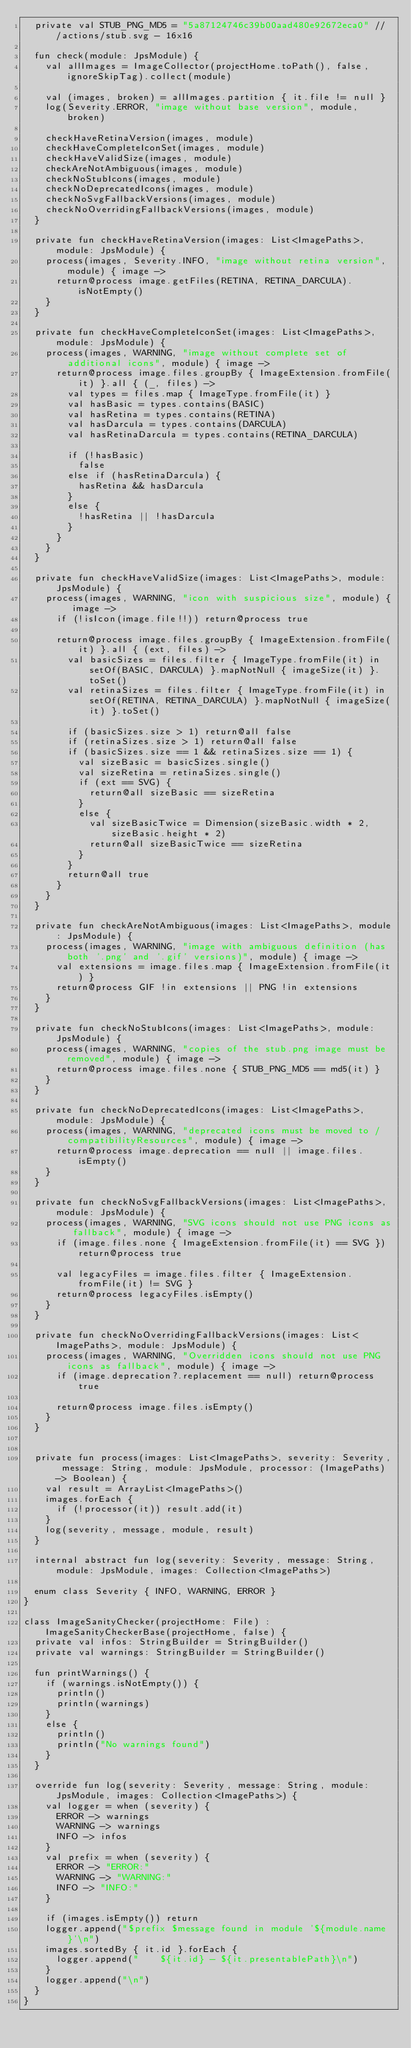Convert code to text. <code><loc_0><loc_0><loc_500><loc_500><_Kotlin_>  private val STUB_PNG_MD5 = "5a87124746c39b00aad480e92672eca0" // /actions/stub.svg - 16x16

  fun check(module: JpsModule) {
    val allImages = ImageCollector(projectHome.toPath(), false, ignoreSkipTag).collect(module)

    val (images, broken) = allImages.partition { it.file != null }
    log(Severity.ERROR, "image without base version", module, broken)

    checkHaveRetinaVersion(images, module)
    checkHaveCompleteIconSet(images, module)
    checkHaveValidSize(images, module)
    checkAreNotAmbiguous(images, module)
    checkNoStubIcons(images, module)
    checkNoDeprecatedIcons(images, module)
    checkNoSvgFallbackVersions(images, module)
    checkNoOverridingFallbackVersions(images, module)
  }

  private fun checkHaveRetinaVersion(images: List<ImagePaths>, module: JpsModule) {
    process(images, Severity.INFO, "image without retina version", module) { image ->
      return@process image.getFiles(RETINA, RETINA_DARCULA).isNotEmpty()
    }
  }

  private fun checkHaveCompleteIconSet(images: List<ImagePaths>, module: JpsModule) {
    process(images, WARNING, "image without complete set of additional icons", module) { image ->
      return@process image.files.groupBy { ImageExtension.fromFile(it) }.all { (_, files) ->
        val types = files.map { ImageType.fromFile(it) }
        val hasBasic = types.contains(BASIC)
        val hasRetina = types.contains(RETINA)
        val hasDarcula = types.contains(DARCULA)
        val hasRetinaDarcula = types.contains(RETINA_DARCULA)

        if (!hasBasic)
          false
        else if (hasRetinaDarcula) {
          hasRetina && hasDarcula
        }
        else {
          !hasRetina || !hasDarcula
        }
      }
    }
  }

  private fun checkHaveValidSize(images: List<ImagePaths>, module: JpsModule) {
    process(images, WARNING, "icon with suspicious size", module) { image ->
      if (!isIcon(image.file!!)) return@process true

      return@process image.files.groupBy { ImageExtension.fromFile(it) }.all { (ext, files) ->
        val basicSizes = files.filter { ImageType.fromFile(it) in setOf(BASIC, DARCULA) }.mapNotNull { imageSize(it) }.toSet()
        val retinaSizes = files.filter { ImageType.fromFile(it) in setOf(RETINA, RETINA_DARCULA) }.mapNotNull { imageSize(it) }.toSet()

        if (basicSizes.size > 1) return@all false
        if (retinaSizes.size > 1) return@all false
        if (basicSizes.size == 1 && retinaSizes.size == 1) {
          val sizeBasic = basicSizes.single()
          val sizeRetina = retinaSizes.single()
          if (ext == SVG) {
            return@all sizeBasic == sizeRetina
          }
          else {
            val sizeBasicTwice = Dimension(sizeBasic.width * 2, sizeBasic.height * 2)
            return@all sizeBasicTwice == sizeRetina
          }
        }
        return@all true
      }
    }
  }

  private fun checkAreNotAmbiguous(images: List<ImagePaths>, module: JpsModule) {
    process(images, WARNING, "image with ambiguous definition (has both '.png' and '.gif' versions)", module) { image ->
      val extensions = image.files.map { ImageExtension.fromFile(it) }
      return@process GIF !in extensions || PNG !in extensions
    }
  }

  private fun checkNoStubIcons(images: List<ImagePaths>, module: JpsModule) {
    process(images, WARNING, "copies of the stub.png image must be removed", module) { image ->
      return@process image.files.none { STUB_PNG_MD5 == md5(it) }
    }
  }

  private fun checkNoDeprecatedIcons(images: List<ImagePaths>, module: JpsModule) {
    process(images, WARNING, "deprecated icons must be moved to /compatibilityResources", module) { image ->
      return@process image.deprecation == null || image.files.isEmpty()
    }
  }

  private fun checkNoSvgFallbackVersions(images: List<ImagePaths>, module: JpsModule) {
    process(images, WARNING, "SVG icons should not use PNG icons as fallback", module) { image ->
      if (image.files.none { ImageExtension.fromFile(it) == SVG }) return@process true

      val legacyFiles = image.files.filter { ImageExtension.fromFile(it) != SVG }
      return@process legacyFiles.isEmpty()
    }
  }

  private fun checkNoOverridingFallbackVersions(images: List<ImagePaths>, module: JpsModule) {
    process(images, WARNING, "Overridden icons should not use PNG icons as fallback", module) { image ->
      if (image.deprecation?.replacement == null) return@process true

      return@process image.files.isEmpty()
    }
  }


  private fun process(images: List<ImagePaths>, severity: Severity, message: String, module: JpsModule, processor: (ImagePaths) -> Boolean) {
    val result = ArrayList<ImagePaths>()
    images.forEach {
      if (!processor(it)) result.add(it)
    }
    log(severity, message, module, result)
  }

  internal abstract fun log(severity: Severity, message: String, module: JpsModule, images: Collection<ImagePaths>)

  enum class Severity { INFO, WARNING, ERROR }
}

class ImageSanityChecker(projectHome: File) : ImageSanityCheckerBase(projectHome, false) {
  private val infos: StringBuilder = StringBuilder()
  private val warnings: StringBuilder = StringBuilder()

  fun printWarnings() {
    if (warnings.isNotEmpty()) {
      println()
      println(warnings)
    }
    else {
      println()
      println("No warnings found")
    }
  }

  override fun log(severity: Severity, message: String, module: JpsModule, images: Collection<ImagePaths>) {
    val logger = when (severity) {
      ERROR -> warnings
      WARNING -> warnings
      INFO -> infos
    }
    val prefix = when (severity) {
      ERROR -> "ERROR:"
      WARNING -> "WARNING:"
      INFO -> "INFO:"
    }

    if (images.isEmpty()) return
    logger.append("$prefix $message found in module '${module.name}'\n")
    images.sortedBy { it.id }.forEach {
      logger.append("    ${it.id} - ${it.presentablePath}\n")
    }
    logger.append("\n")
  }
}
</code> 